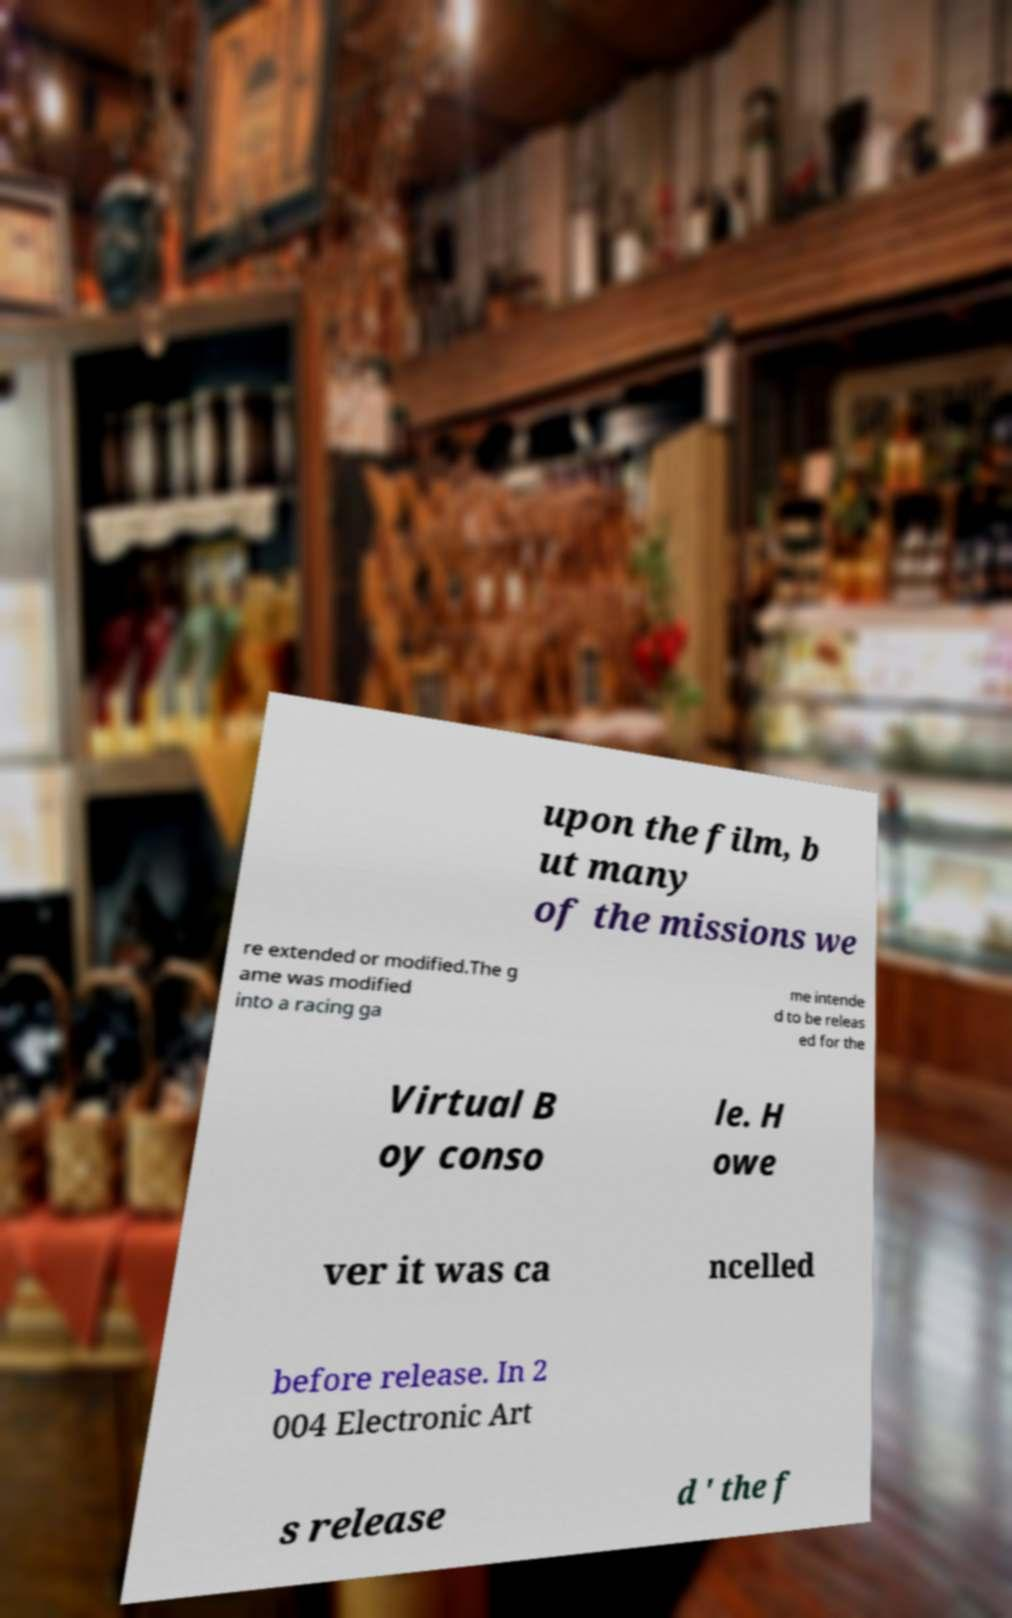For documentation purposes, I need the text within this image transcribed. Could you provide that? upon the film, b ut many of the missions we re extended or modified.The g ame was modified into a racing ga me intende d to be releas ed for the Virtual B oy conso le. H owe ver it was ca ncelled before release. In 2 004 Electronic Art s release d ' the f 